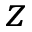<formula> <loc_0><loc_0><loc_500><loc_500>z</formula> 